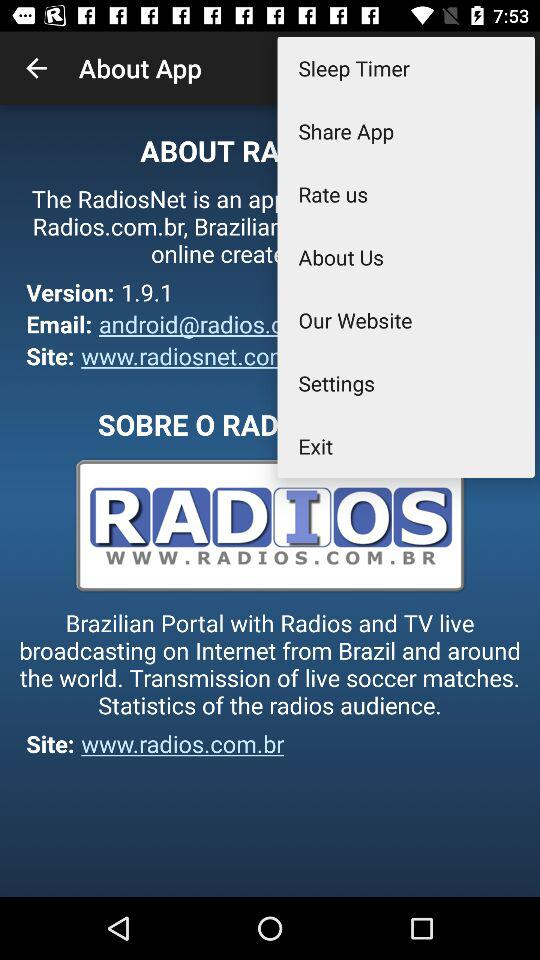What is the name of the application? The name of the application is "RadiosNet". 